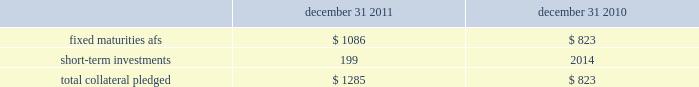The hartford financial services group , inc .
Notes to consolidated financial statements ( continued ) 5 .
Investments and derivative instruments ( continued ) collateral arrangements the company enters into various collateral arrangements in connection with its derivative instruments , which require both the pledging and accepting of collateral .
As of december 31 , 2011 and 2010 , collateral pledged having a fair value of $ 1.1 billion and $ 790 , respectively , was included in fixed maturities , afs , in the consolidated balance sheets .
From time to time , the company enters into secured borrowing arrangements as a means to increase net investment income .
The company received cash collateral of $ 33 as of december 31 , 2011 and 2010 .
The table presents the classification and carrying amount of loaned securities and derivative instruments collateral pledged. .
As of december 31 , 2011 and 2010 , the company had accepted collateral with a fair value of $ 2.6 billion and $ 1.5 billion , respectively , of which $ 2.0 billion and $ 1.1 billion , respectively , was cash collateral which was invested and recorded in the consolidated balance sheets in fixed maturities and short-term investments with corresponding amounts recorded in other assets and other liabilities .
The company is only permitted by contract to sell or repledge the noncash collateral in the event of a default by the counterparty .
As of december 31 , 2011 and 2010 , noncash collateral accepted was held in separate custodial accounts and was not included in the company 2019s consolidated balance sheets .
Securities on deposit with states the company is required by law to deposit securities with government agencies in states where it conducts business .
As of december 31 , 2011 and 2010 , the fair value of securities on deposit was approximately $ 1.6 billion and $ 1.4 billion , respectively. .
In 2011 what was the percent of the total collateral loaned securities and derivative instruments collateral pledged that was associated with short-term investments? 
Computations: (199 / 1285)
Answer: 0.15486. 